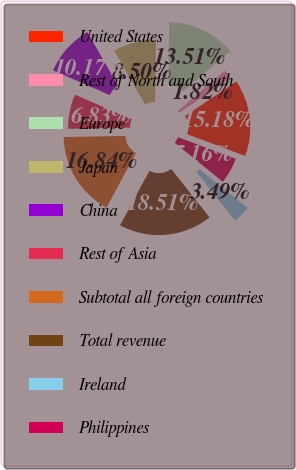Convert chart. <chart><loc_0><loc_0><loc_500><loc_500><pie_chart><fcel>United States<fcel>Rest of North and South<fcel>Europe<fcel>Japan<fcel>China<fcel>Rest of Asia<fcel>Subtotal all foreign countries<fcel>Total revenue<fcel>Ireland<fcel>Philippines<nl><fcel>15.18%<fcel>1.82%<fcel>13.51%<fcel>8.5%<fcel>10.17%<fcel>6.83%<fcel>16.85%<fcel>18.52%<fcel>3.49%<fcel>5.16%<nl></chart> 